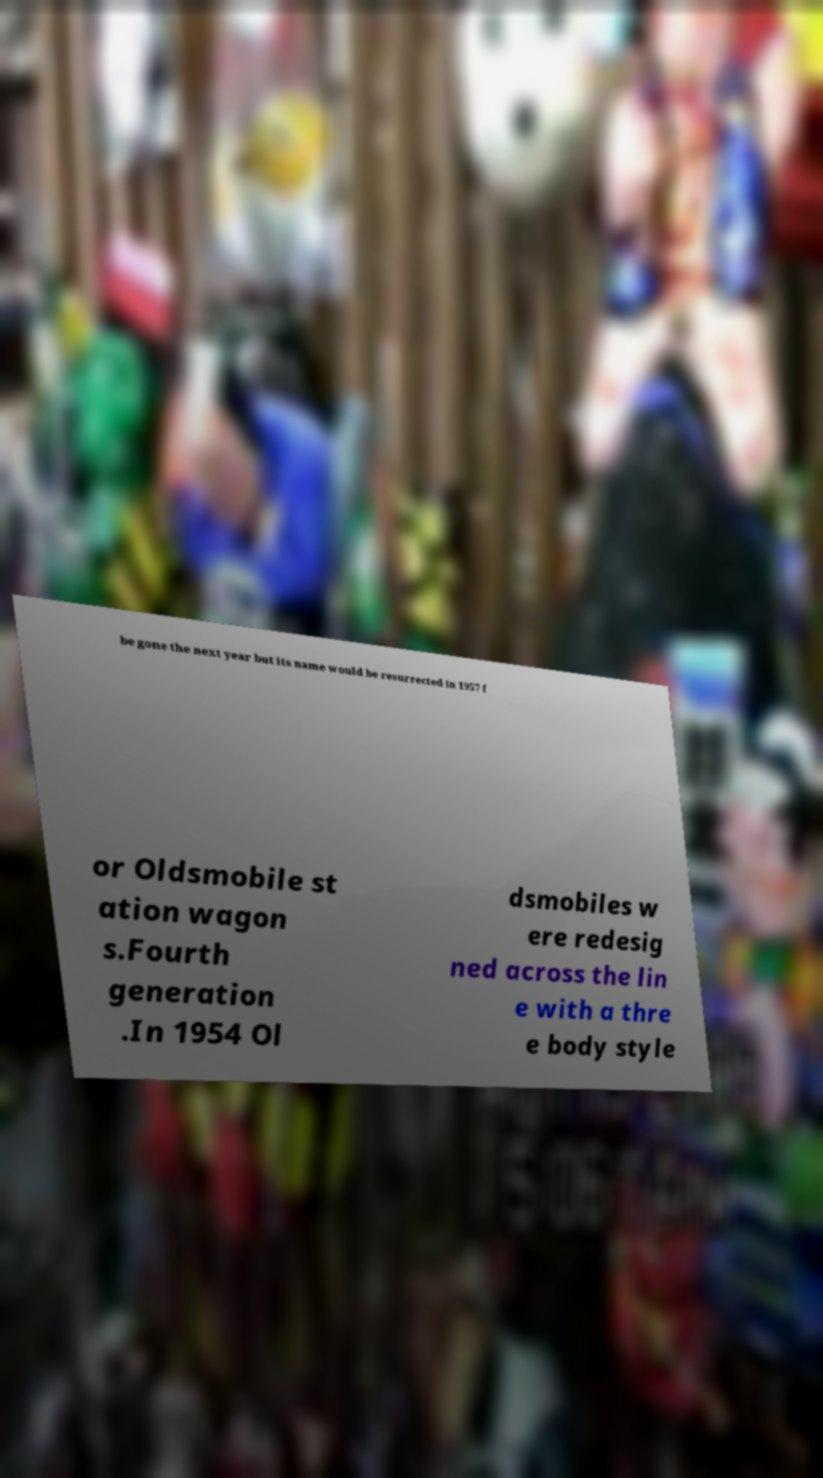Can you read and provide the text displayed in the image?This photo seems to have some interesting text. Can you extract and type it out for me? be gone the next year but its name would be resurrected in 1957 f or Oldsmobile st ation wagon s.Fourth generation .In 1954 Ol dsmobiles w ere redesig ned across the lin e with a thre e body style 